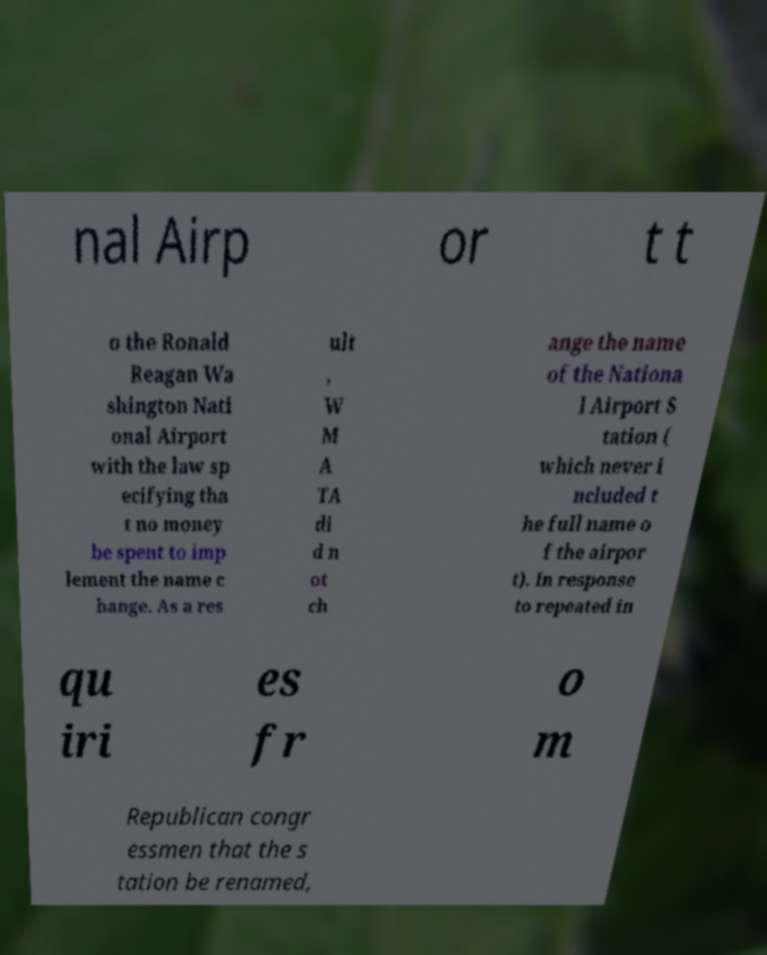I need the written content from this picture converted into text. Can you do that? nal Airp or t t o the Ronald Reagan Wa shington Nati onal Airport with the law sp ecifying tha t no money be spent to imp lement the name c hange. As a res ult , W M A TA di d n ot ch ange the name of the Nationa l Airport S tation ( which never i ncluded t he full name o f the airpor t). In response to repeated in qu iri es fr o m Republican congr essmen that the s tation be renamed, 